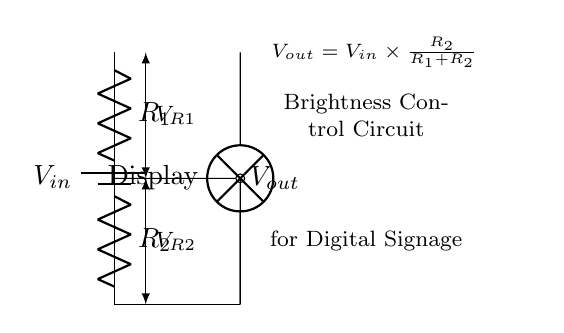What is the input voltage of this circuit? The input voltage is represented as V_in in the circuit. It is the voltage supplied to the entire circuit from the battery.
Answer: V_in What components are present in the circuit? The circuit contains two resistors (R1 and R2), a battery (V_in), and a display (lamp). These components are clearly labeled in the diagram.
Answer: Two resistors, a battery, and a display What is the output voltage formula in this circuit? The output voltage V_out is given by the formula V_out = V_in × (R2 / (R1 + R2)). This is shown in the node on the right in the diagram.
Answer: V_out = V_in × (R2 / (R1 + R2)) How does changing R1 affect V_out? Increasing R1 would increase the total resistance in the denominator (R1 + R2), which would result in a smaller V_out. Hence, V_out is inversely proportional to R1.
Answer: V_out decreases What is the role of the resistors in this circuit? The resistors R1 and R2 form a voltage divider that adjusts the output voltage V_out, which controls the brightness of the display connected to the circuit.
Answer: Voltage divider If R2 is halved, what happens to V_out? Halving R2 decreases its contribution to the output voltage formula, resulting in a lower V_out. Since R2 is in the numerator, reducing it causes a decrease in the output voltage value.
Answer: V_out decreases 